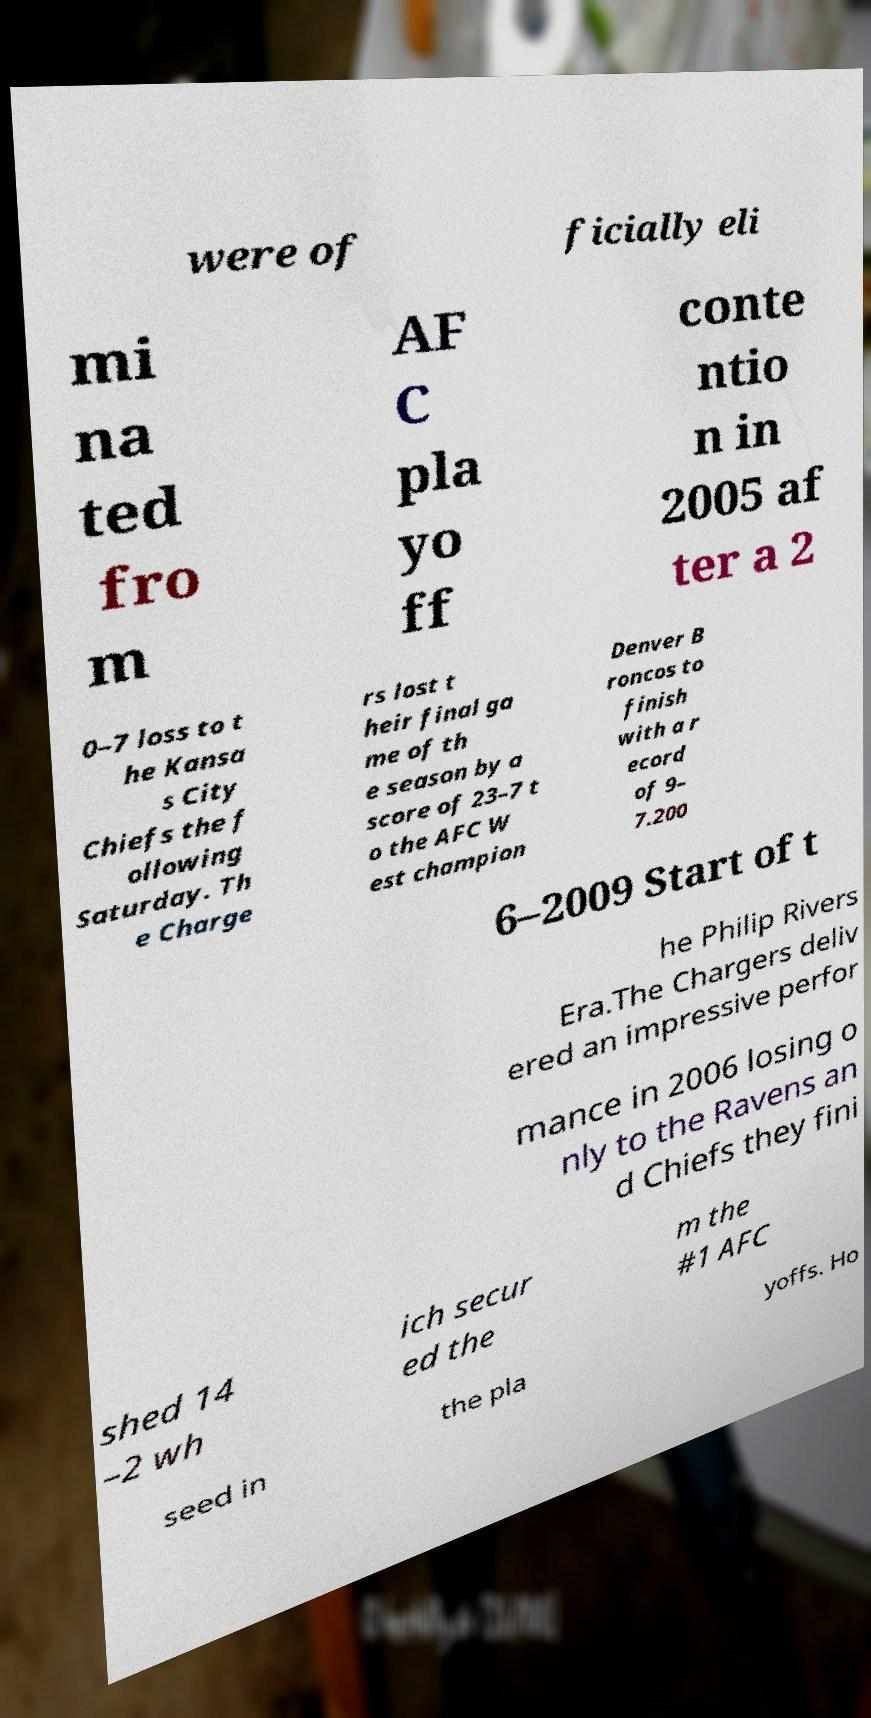Please read and relay the text visible in this image. What does it say? were of ficially eli mi na ted fro m AF C pla yo ff conte ntio n in 2005 af ter a 2 0–7 loss to t he Kansa s City Chiefs the f ollowing Saturday. Th e Charge rs lost t heir final ga me of th e season by a score of 23–7 t o the AFC W est champion Denver B roncos to finish with a r ecord of 9– 7.200 6–2009 Start of t he Philip Rivers Era.The Chargers deliv ered an impressive perfor mance in 2006 losing o nly to the Ravens an d Chiefs they fini shed 14 –2 wh ich secur ed the m the #1 AFC seed in the pla yoffs. Ho 